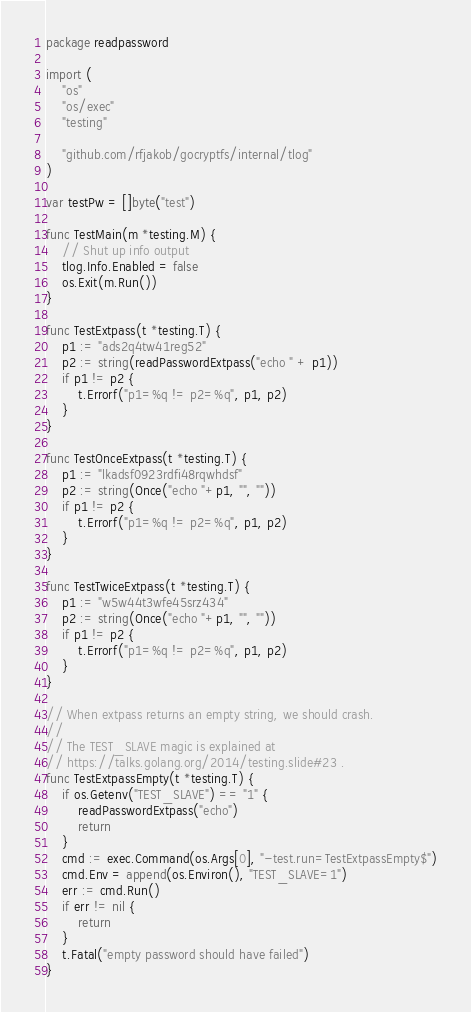Convert code to text. <code><loc_0><loc_0><loc_500><loc_500><_Go_>package readpassword

import (
	"os"
	"os/exec"
	"testing"

	"github.com/rfjakob/gocryptfs/internal/tlog"
)

var testPw = []byte("test")

func TestMain(m *testing.M) {
	// Shut up info output
	tlog.Info.Enabled = false
	os.Exit(m.Run())
}

func TestExtpass(t *testing.T) {
	p1 := "ads2q4tw41reg52"
	p2 := string(readPasswordExtpass("echo " + p1))
	if p1 != p2 {
		t.Errorf("p1=%q != p2=%q", p1, p2)
	}
}

func TestOnceExtpass(t *testing.T) {
	p1 := "lkadsf0923rdfi48rqwhdsf"
	p2 := string(Once("echo "+p1, "", ""))
	if p1 != p2 {
		t.Errorf("p1=%q != p2=%q", p1, p2)
	}
}

func TestTwiceExtpass(t *testing.T) {
	p1 := "w5w44t3wfe45srz434"
	p2 := string(Once("echo "+p1, "", ""))
	if p1 != p2 {
		t.Errorf("p1=%q != p2=%q", p1, p2)
	}
}

// When extpass returns an empty string, we should crash.
//
// The TEST_SLAVE magic is explained at
// https://talks.golang.org/2014/testing.slide#23 .
func TestExtpassEmpty(t *testing.T) {
	if os.Getenv("TEST_SLAVE") == "1" {
		readPasswordExtpass("echo")
		return
	}
	cmd := exec.Command(os.Args[0], "-test.run=TestExtpassEmpty$")
	cmd.Env = append(os.Environ(), "TEST_SLAVE=1")
	err := cmd.Run()
	if err != nil {
		return
	}
	t.Fatal("empty password should have failed")
}
</code> 